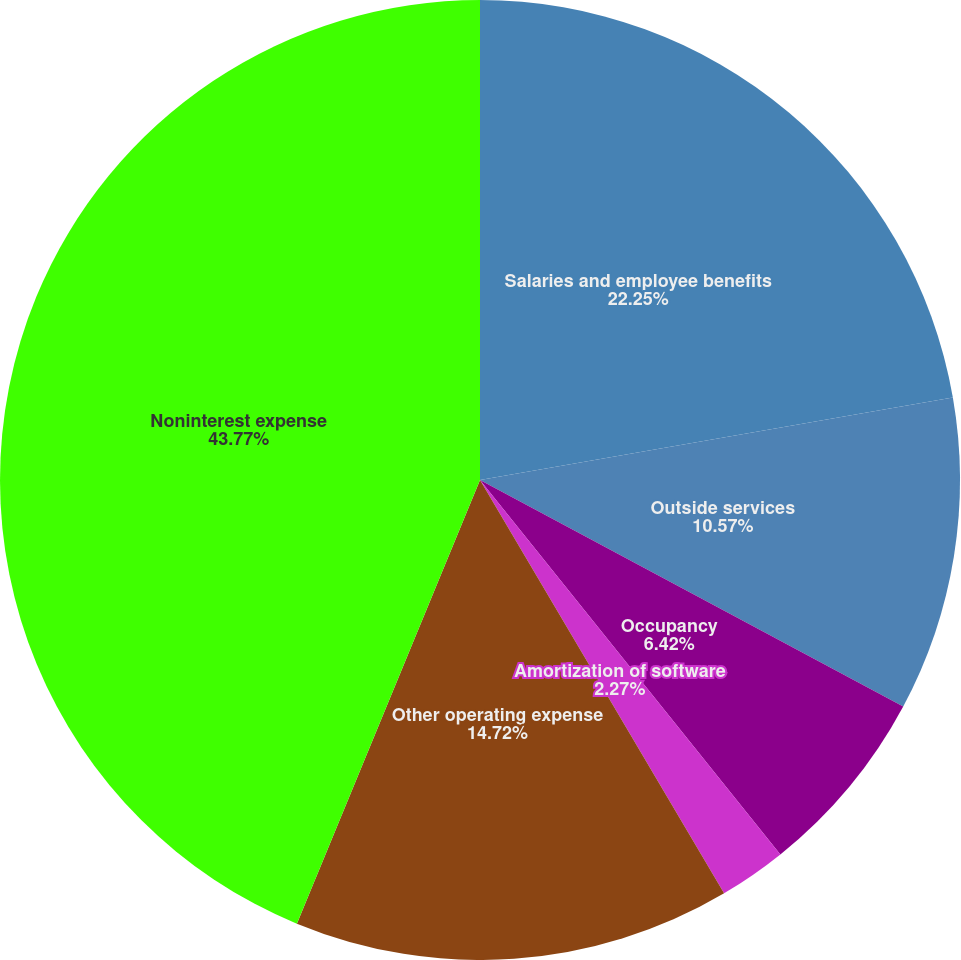<chart> <loc_0><loc_0><loc_500><loc_500><pie_chart><fcel>Salaries and employee benefits<fcel>Outside services<fcel>Occupancy<fcel>Amortization of software<fcel>Other operating expense<fcel>Noninterest expense<nl><fcel>22.25%<fcel>10.57%<fcel>6.42%<fcel>2.27%<fcel>14.72%<fcel>43.77%<nl></chart> 